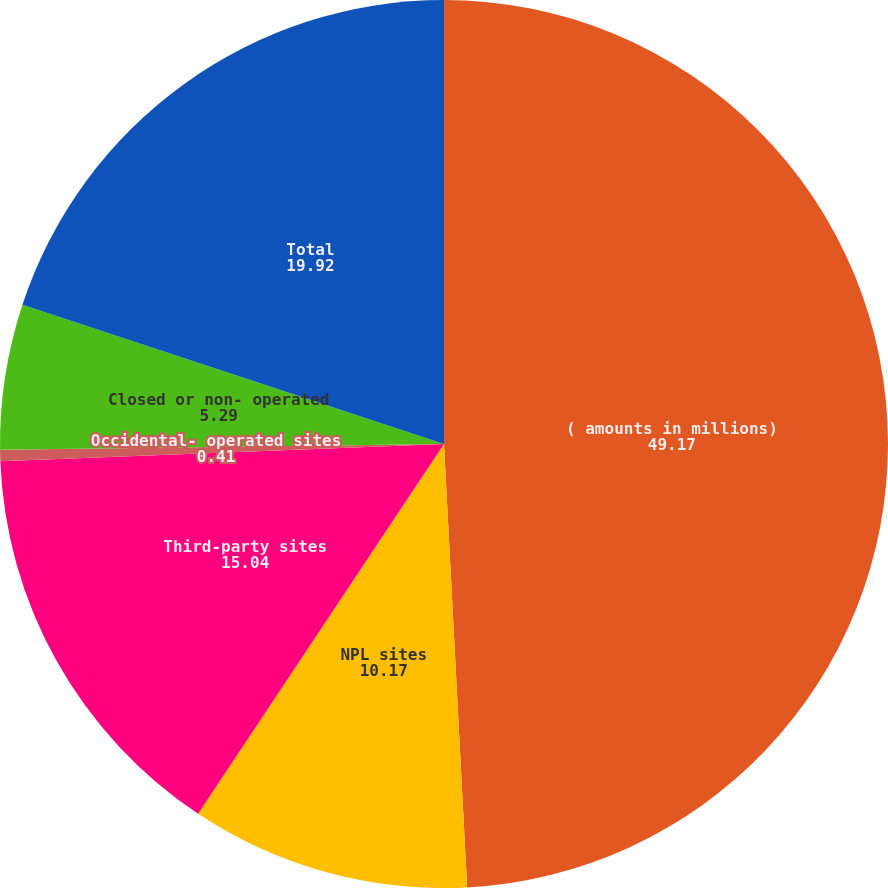<chart> <loc_0><loc_0><loc_500><loc_500><pie_chart><fcel>( amounts in millions)<fcel>NPL sites<fcel>Third-party sites<fcel>Occidental- operated sites<fcel>Closed or non- operated<fcel>Total<nl><fcel>49.17%<fcel>10.17%<fcel>15.04%<fcel>0.41%<fcel>5.29%<fcel>19.92%<nl></chart> 